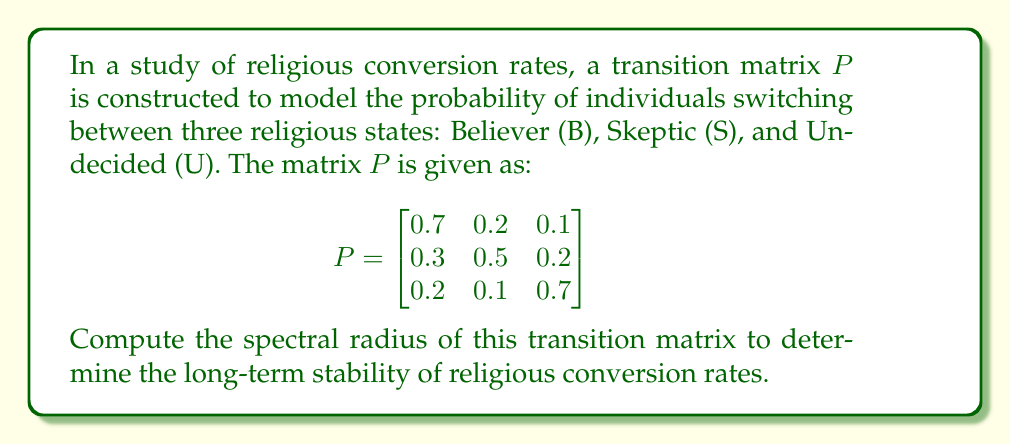Could you help me with this problem? To find the spectral radius of the transition matrix $P$, we need to follow these steps:

1) First, recall that the spectral radius $\rho(P)$ is the maximum absolute value of the eigenvalues of $P$.

2) To find the eigenvalues, we need to solve the characteristic equation:
   $\det(P - \lambda I) = 0$

3) Expanding this determinant:
   $$\begin{vmatrix}
   0.7-\lambda & 0.2 & 0.1 \\
   0.3 & 0.5-\lambda & 0.2 \\
   0.2 & 0.1 & 0.7-\lambda
   \end{vmatrix} = 0$$

4) This expands to:
   $(0.7-\lambda)[(0.5-\lambda)(0.7-\lambda)-0.02] - 0.2[0.3(0.7-\lambda)-0.06] + 0.1[0.06-0.3(0.5-\lambda)] = 0$

5) Simplifying:
   $-\lambda^3 + 1.9\lambda^2 - 1.14\lambda + 0.21 = 0$

6) This cubic equation can be solved using various methods. Using a computer algebra system or numerical methods, we find the roots (eigenvalues) to be approximately:
   $\lambda_1 \approx 1$
   $\lambda_2 \approx 0.5789$
   $\lambda_3 \approx 0.3211$

7) The spectral radius is the maximum absolute value of these eigenvalues:
   $\rho(P) = \max(|\lambda_1|, |\lambda_2|, |\lambda_3|) = |\lambda_1| = 1$

8) Note: For a stochastic matrix like this transition matrix, the spectral radius is always 1, which corresponds to the stationary distribution.
Answer: $\rho(P) = 1$ 